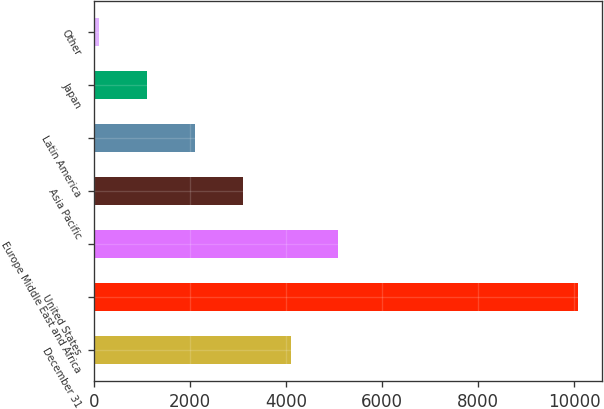<chart> <loc_0><loc_0><loc_500><loc_500><bar_chart><fcel>December 31<fcel>United States<fcel>Europe Middle East and Africa<fcel>Asia Pacific<fcel>Latin America<fcel>Japan<fcel>Other<nl><fcel>4088.6<fcel>10076<fcel>5086.5<fcel>3090.7<fcel>2092.8<fcel>1094.9<fcel>97<nl></chart> 